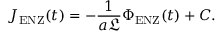<formula> <loc_0><loc_0><loc_500><loc_500>J _ { E N Z } ( t ) = - \frac { 1 } { a \mathfrak { L } } \Phi _ { E N Z } ( t ) + C .</formula> 